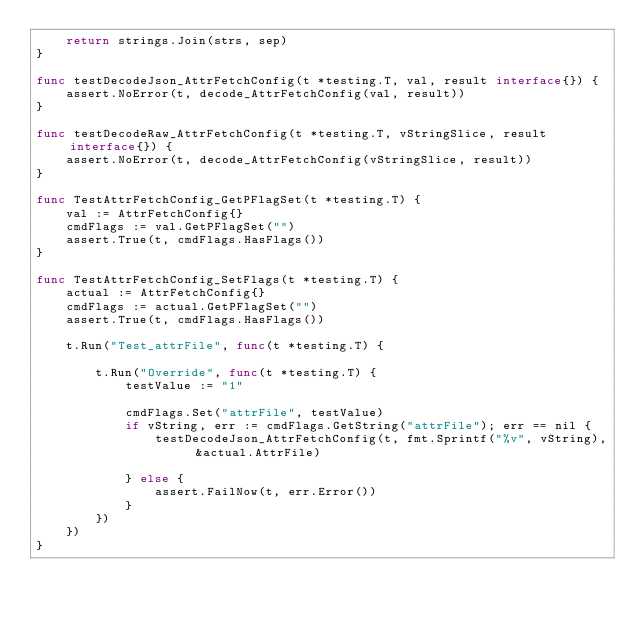<code> <loc_0><loc_0><loc_500><loc_500><_Go_>	return strings.Join(strs, sep)
}

func testDecodeJson_AttrFetchConfig(t *testing.T, val, result interface{}) {
	assert.NoError(t, decode_AttrFetchConfig(val, result))
}

func testDecodeRaw_AttrFetchConfig(t *testing.T, vStringSlice, result interface{}) {
	assert.NoError(t, decode_AttrFetchConfig(vStringSlice, result))
}

func TestAttrFetchConfig_GetPFlagSet(t *testing.T) {
	val := AttrFetchConfig{}
	cmdFlags := val.GetPFlagSet("")
	assert.True(t, cmdFlags.HasFlags())
}

func TestAttrFetchConfig_SetFlags(t *testing.T) {
	actual := AttrFetchConfig{}
	cmdFlags := actual.GetPFlagSet("")
	assert.True(t, cmdFlags.HasFlags())

	t.Run("Test_attrFile", func(t *testing.T) {

		t.Run("Override", func(t *testing.T) {
			testValue := "1"

			cmdFlags.Set("attrFile", testValue)
			if vString, err := cmdFlags.GetString("attrFile"); err == nil {
				testDecodeJson_AttrFetchConfig(t, fmt.Sprintf("%v", vString), &actual.AttrFile)

			} else {
				assert.FailNow(t, err.Error())
			}
		})
	})
}
</code> 